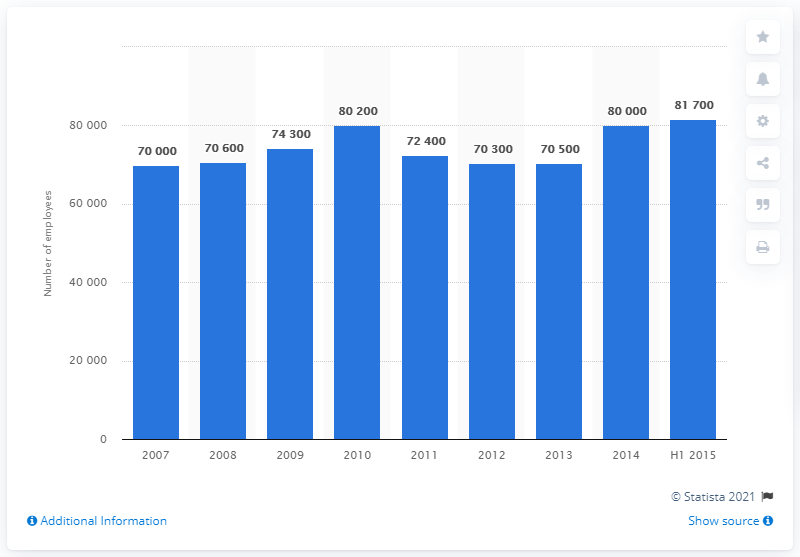Specify some key components in this picture. The employment figures for the insurance sector in London were published in 2007. 